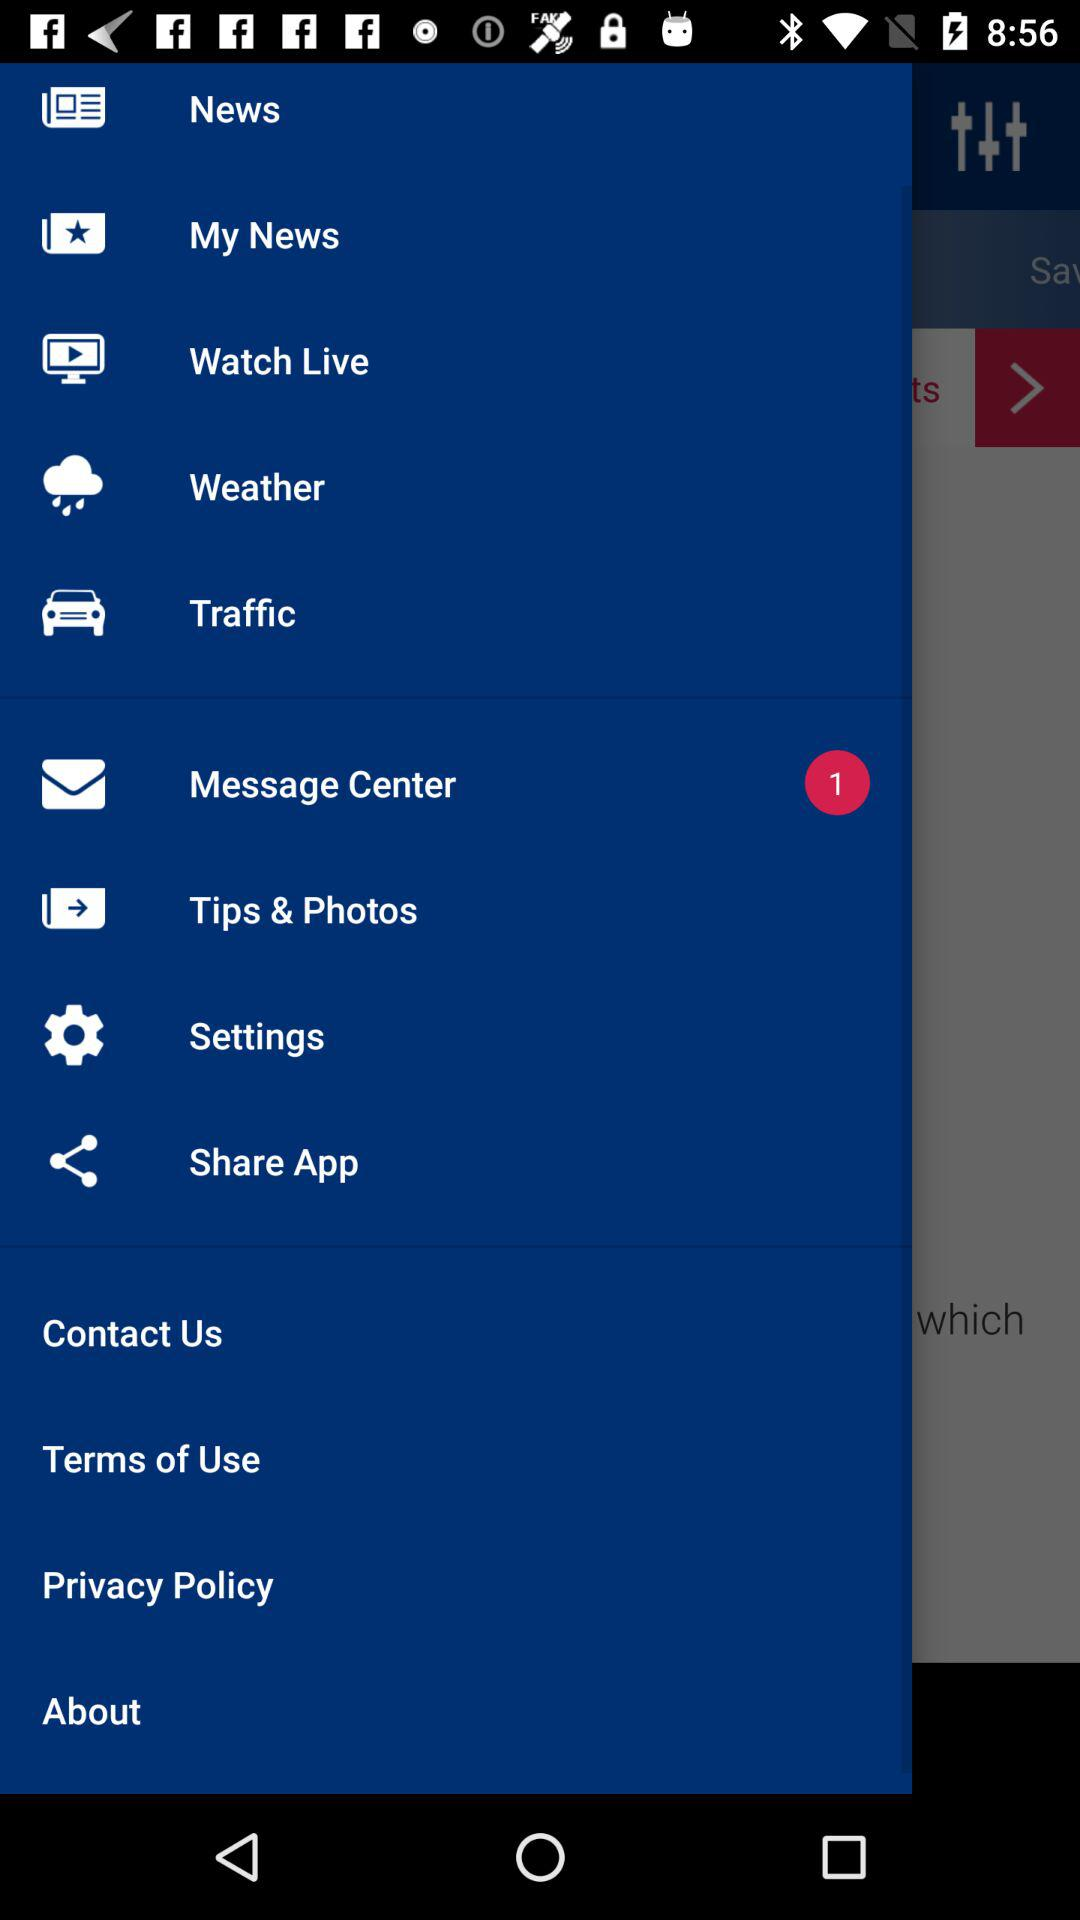How many unread messages are there? There is 1 unread message. 